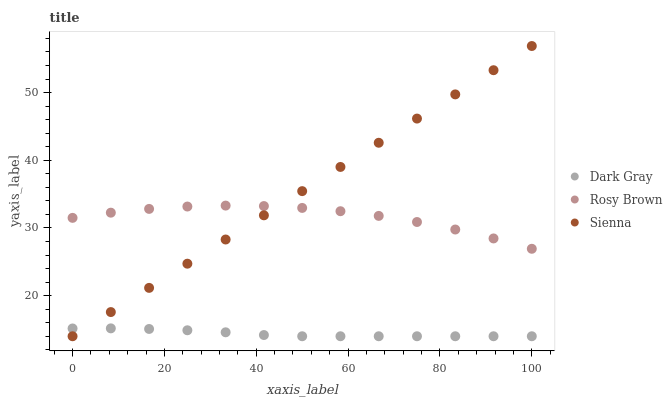Does Dark Gray have the minimum area under the curve?
Answer yes or no. Yes. Does Sienna have the maximum area under the curve?
Answer yes or no. Yes. Does Rosy Brown have the minimum area under the curve?
Answer yes or no. No. Does Rosy Brown have the maximum area under the curve?
Answer yes or no. No. Is Sienna the smoothest?
Answer yes or no. Yes. Is Rosy Brown the roughest?
Answer yes or no. Yes. Is Rosy Brown the smoothest?
Answer yes or no. No. Is Sienna the roughest?
Answer yes or no. No. Does Dark Gray have the lowest value?
Answer yes or no. Yes. Does Rosy Brown have the lowest value?
Answer yes or no. No. Does Sienna have the highest value?
Answer yes or no. Yes. Does Rosy Brown have the highest value?
Answer yes or no. No. Is Dark Gray less than Rosy Brown?
Answer yes or no. Yes. Is Rosy Brown greater than Dark Gray?
Answer yes or no. Yes. Does Rosy Brown intersect Sienna?
Answer yes or no. Yes. Is Rosy Brown less than Sienna?
Answer yes or no. No. Is Rosy Brown greater than Sienna?
Answer yes or no. No. Does Dark Gray intersect Rosy Brown?
Answer yes or no. No. 